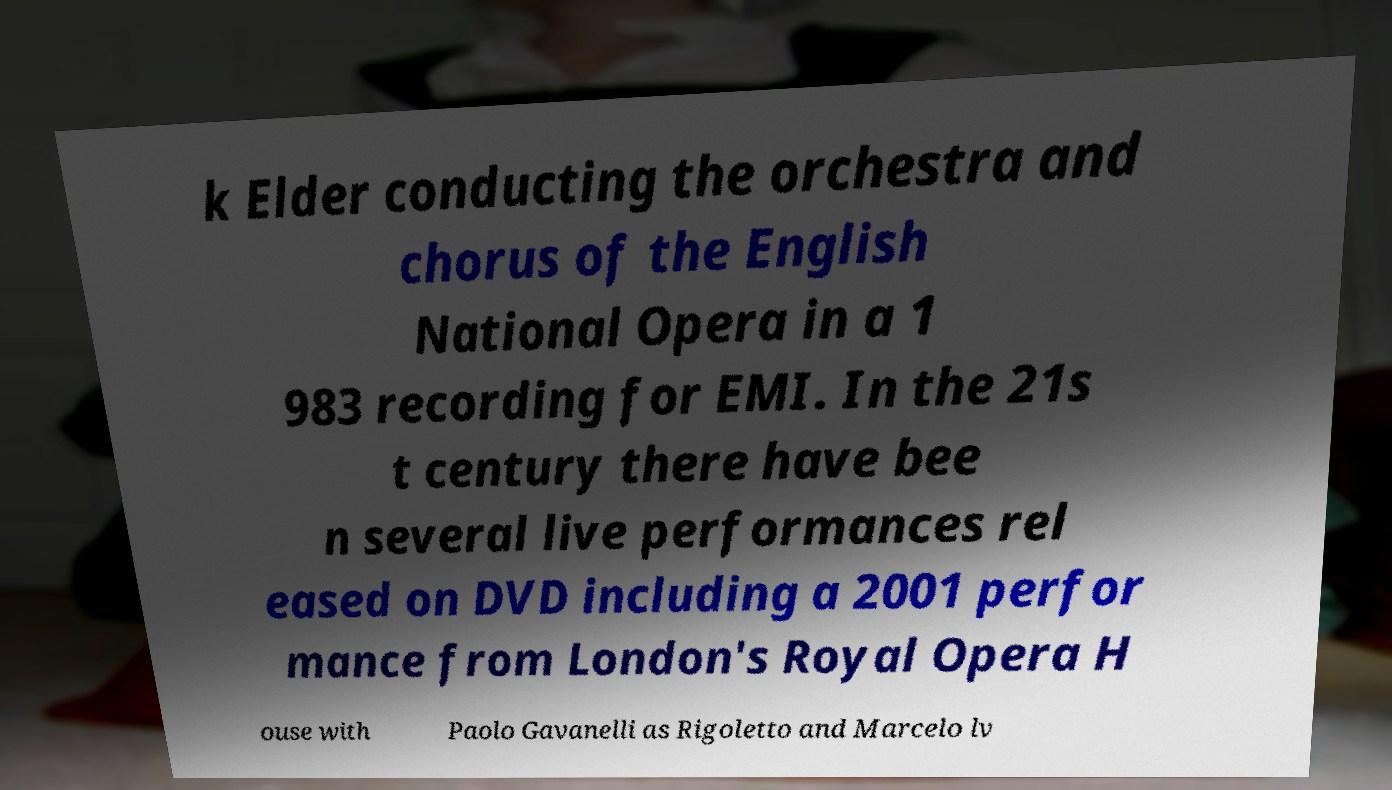What messages or text are displayed in this image? I need them in a readable, typed format. k Elder conducting the orchestra and chorus of the English National Opera in a 1 983 recording for EMI. In the 21s t century there have bee n several live performances rel eased on DVD including a 2001 perfor mance from London's Royal Opera H ouse with Paolo Gavanelli as Rigoletto and Marcelo lv 